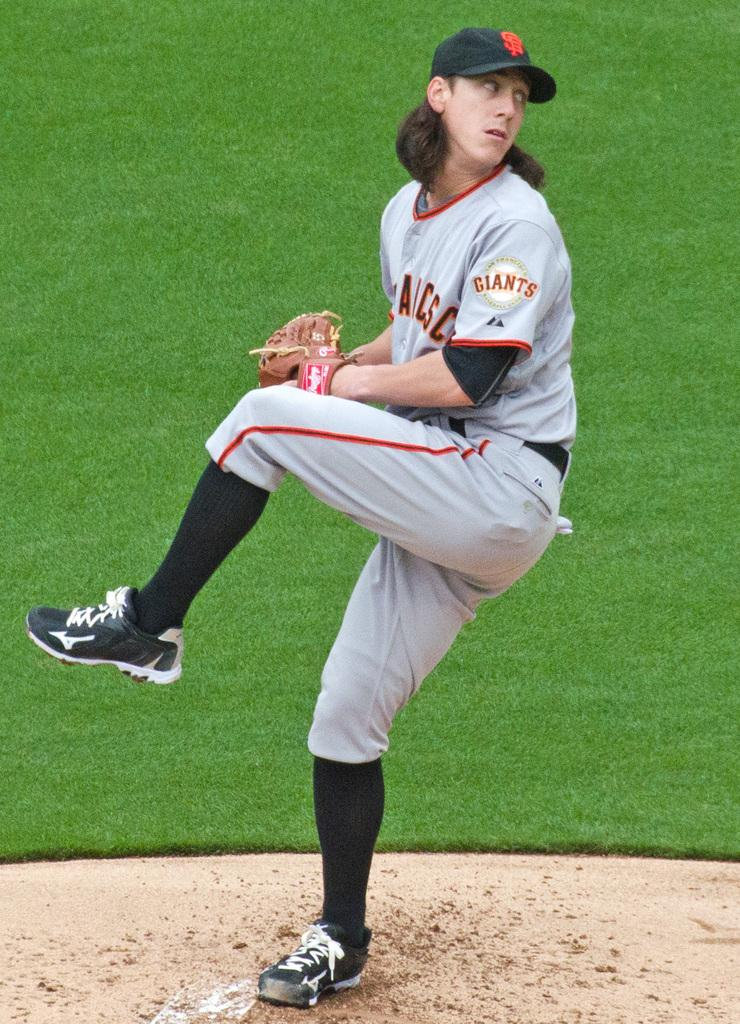What is the main subject of the image? There is a person standing in the image. Where is the person standing? The person is standing on the ground. What is the person wearing on their head? The person is wearing a cap. What type of terrain can be seen in the background of the image? There is grassy land visible in the background of the image. What type of plants can be seen growing in the cellar in the image? There is no cellar present in the image, and therefore no plants can be seen growing in it. 